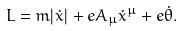Convert formula to latex. <formula><loc_0><loc_0><loc_500><loc_500>L = m | \dot { x } | + e A _ { \mu } \dot { x } ^ { \mu } + e \dot { \theta } .</formula> 